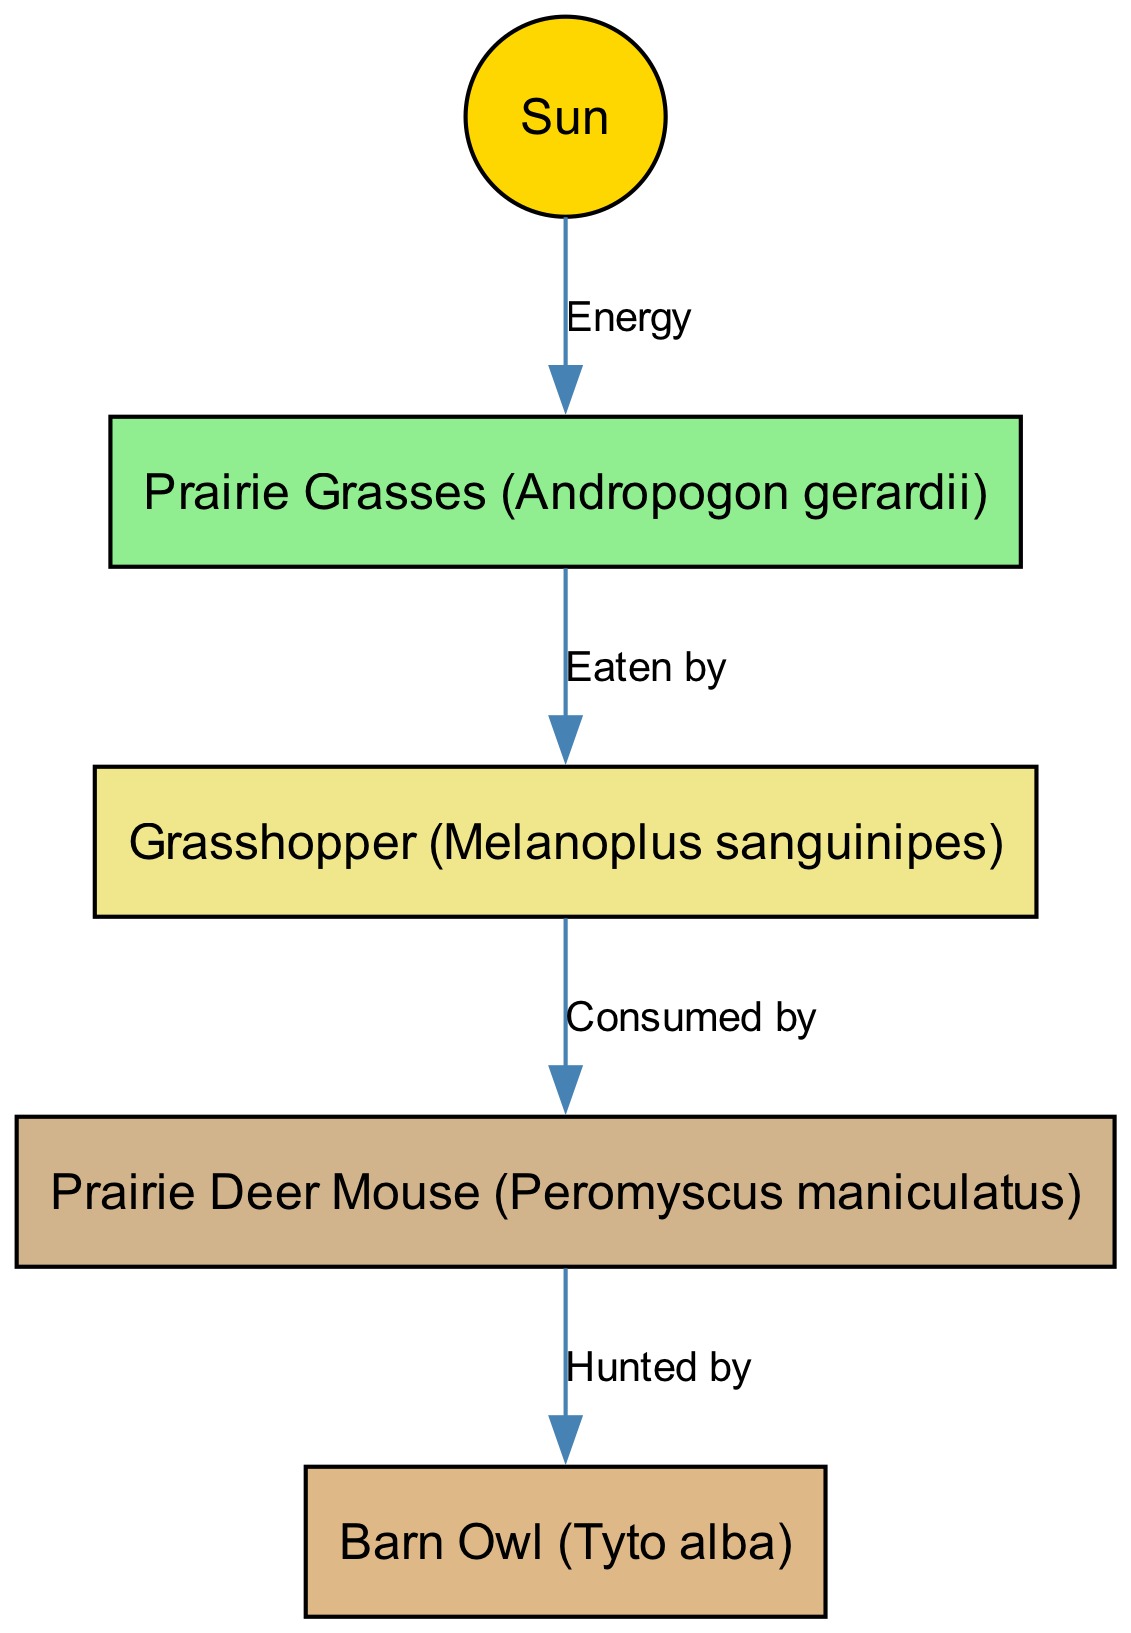What is the primary source of energy in the food chain? The diagram indicates that the "Sun" is the first node and is labeled as providing "Energy." This shows that it is the primary source of energy for the entire food chain depicted.
Answer: Sun How many nodes are in the diagram? By counting the nodes listed in the provided data, there are five nodes: Sun, Prairie Grasses, Grasshopper, Prairie Deer Mouse, and Barn Owl. Therefore, the total number of nodes is five.
Answer: 5 What type of organism is the Barn Owl? The node labeled "Barn Owl" gives its scientific name as "Tyto alba." Since it is positioned at the end of the food chain and is labeled "Hunted by," it represents a predator in this ecosystem. Therefore, the Barn Owl is a predator.
Answer: Predator Which organism is directly eaten by the Grasshopper? The edge from "Grasshopper" to "Prairie Deer Mouse" is labeled "Consumed by," indicating the Grasshopper eats the Prairie Deer Mouse. Thus, the Prairie Deer Mouse is eaten by the Grasshopper.
Answer: Prairie Deer Mouse Identify the relationship between Prairie Grasses and the Grasshopper? The edge between the "Prairie Grasses" node and the "Grasshopper" node is labeled "Eaten by." This means that the Grasshopper consumes the Prairie Grasses, establishing a direct predator-prey relationship.
Answer: Eaten by 